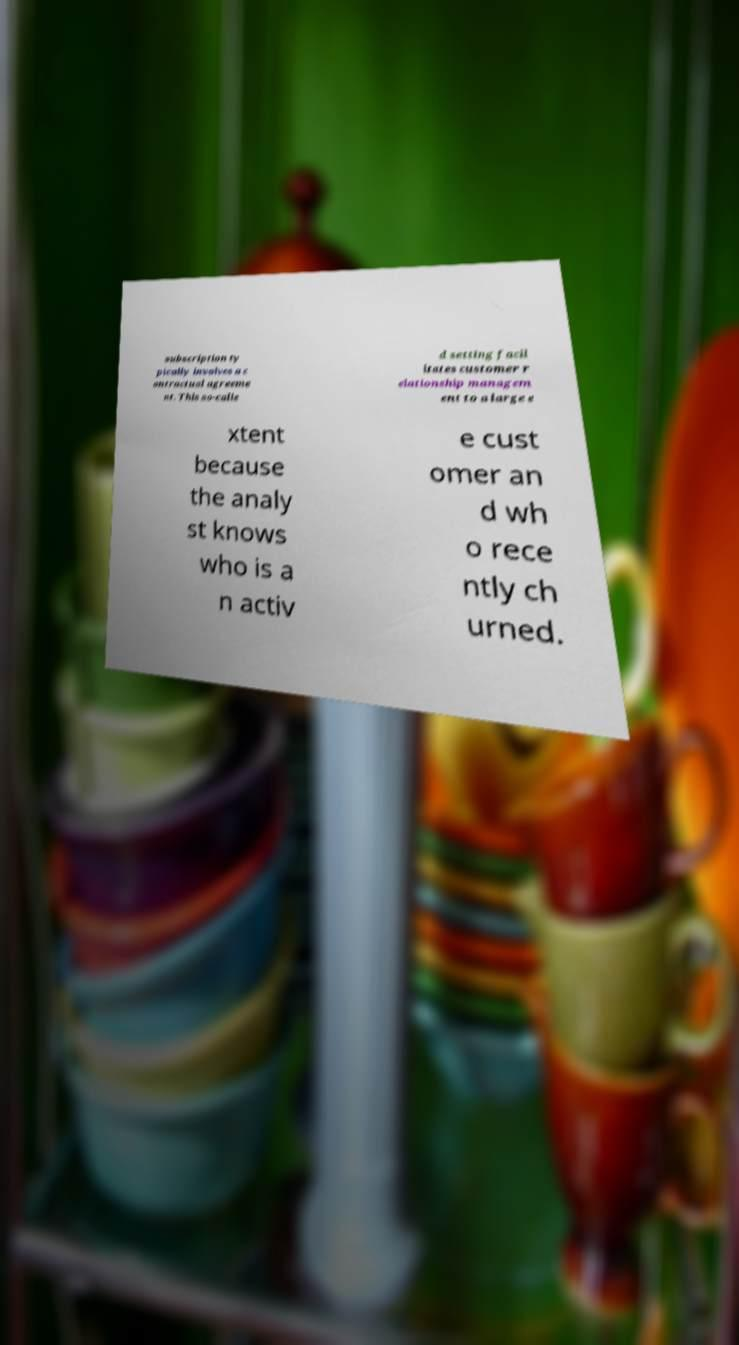What messages or text are displayed in this image? I need them in a readable, typed format. subscription ty pically involves a c ontractual agreeme nt. This so-calle d setting facil itates customer r elationship managem ent to a large e xtent because the analy st knows who is a n activ e cust omer an d wh o rece ntly ch urned. 